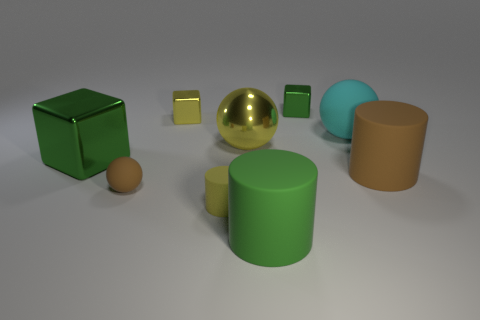Subtract all balls. How many objects are left? 6 Subtract all yellow cylinders. Subtract all rubber spheres. How many objects are left? 6 Add 9 tiny yellow shiny things. How many tiny yellow shiny things are left? 10 Add 9 big cyan rubber objects. How many big cyan rubber objects exist? 10 Subtract 1 brown spheres. How many objects are left? 8 